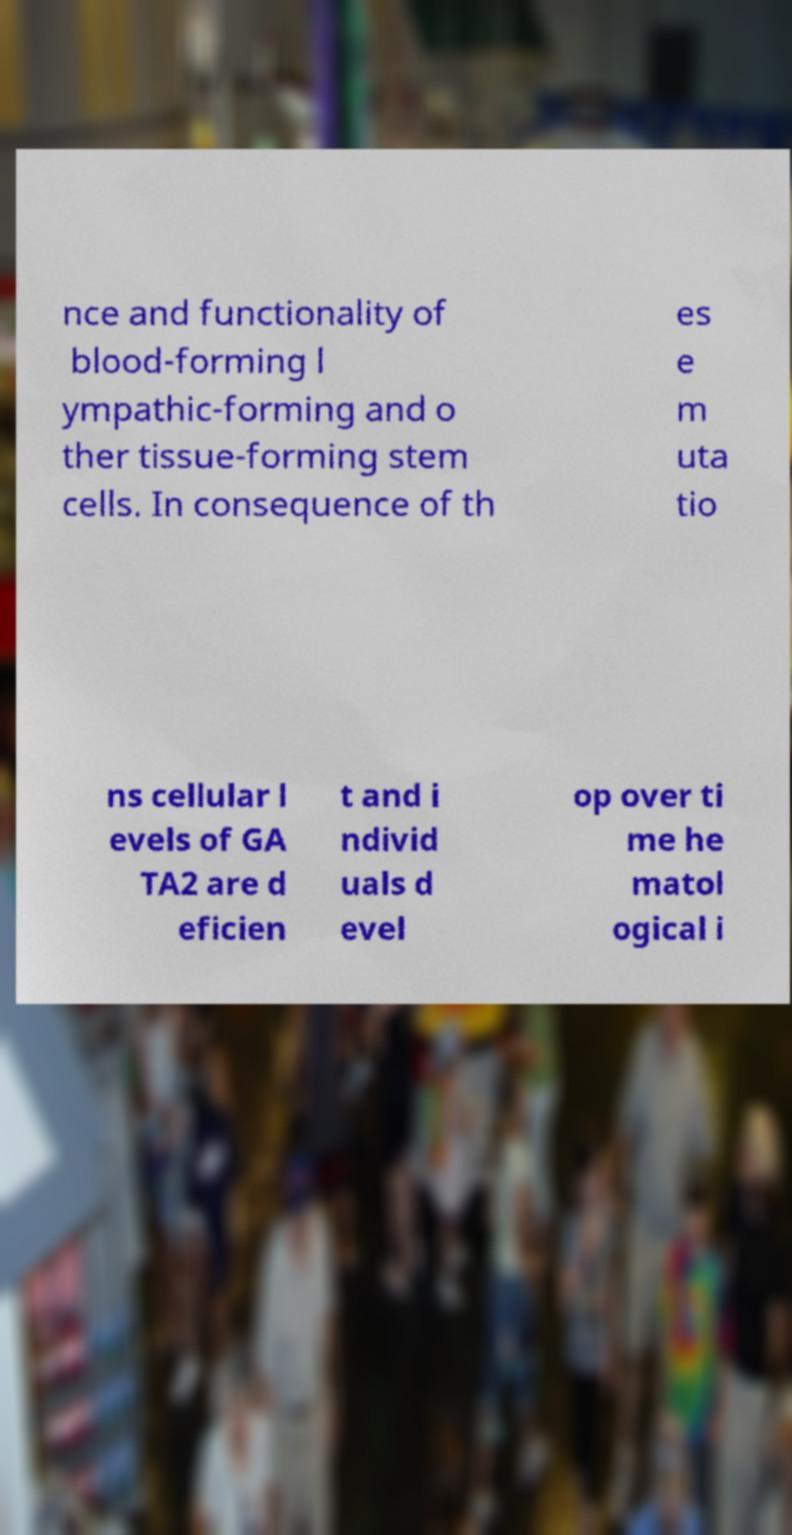Can you read and provide the text displayed in the image?This photo seems to have some interesting text. Can you extract and type it out for me? nce and functionality of blood-forming l ympathic-forming and o ther tissue-forming stem cells. In consequence of th es e m uta tio ns cellular l evels of GA TA2 are d eficien t and i ndivid uals d evel op over ti me he matol ogical i 